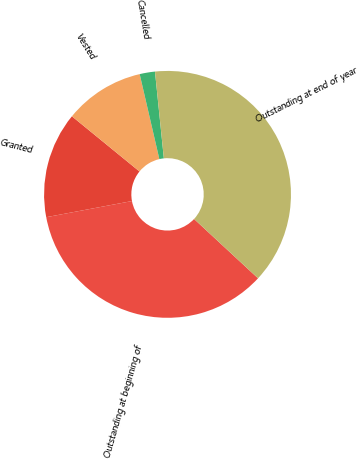Convert chart. <chart><loc_0><loc_0><loc_500><loc_500><pie_chart><fcel>Outstanding at beginning of<fcel>Granted<fcel>Vested<fcel>Cancelled<fcel>Outstanding at end of year<nl><fcel>35.14%<fcel>13.86%<fcel>10.48%<fcel>2.0%<fcel>38.52%<nl></chart> 